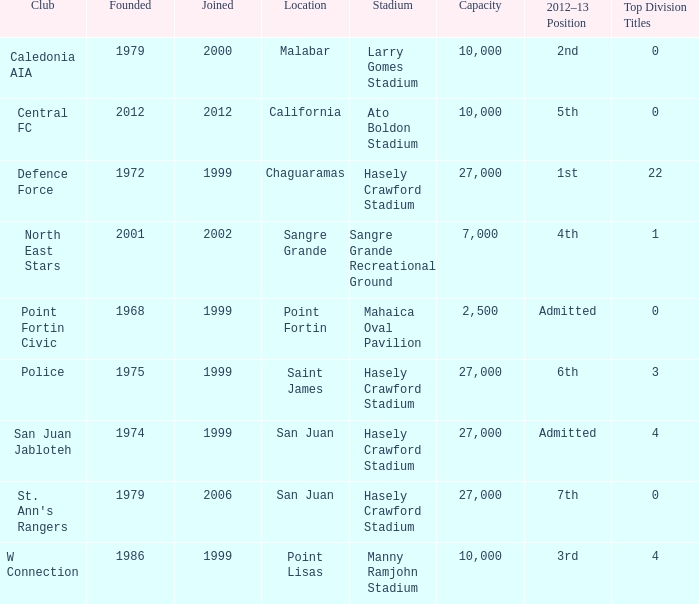How many top division titles were won by teams founded before 1975 and located in chaguaramas? 22.0. 